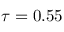<formula> <loc_0><loc_0><loc_500><loc_500>\tau = 0 . 5 5</formula> 